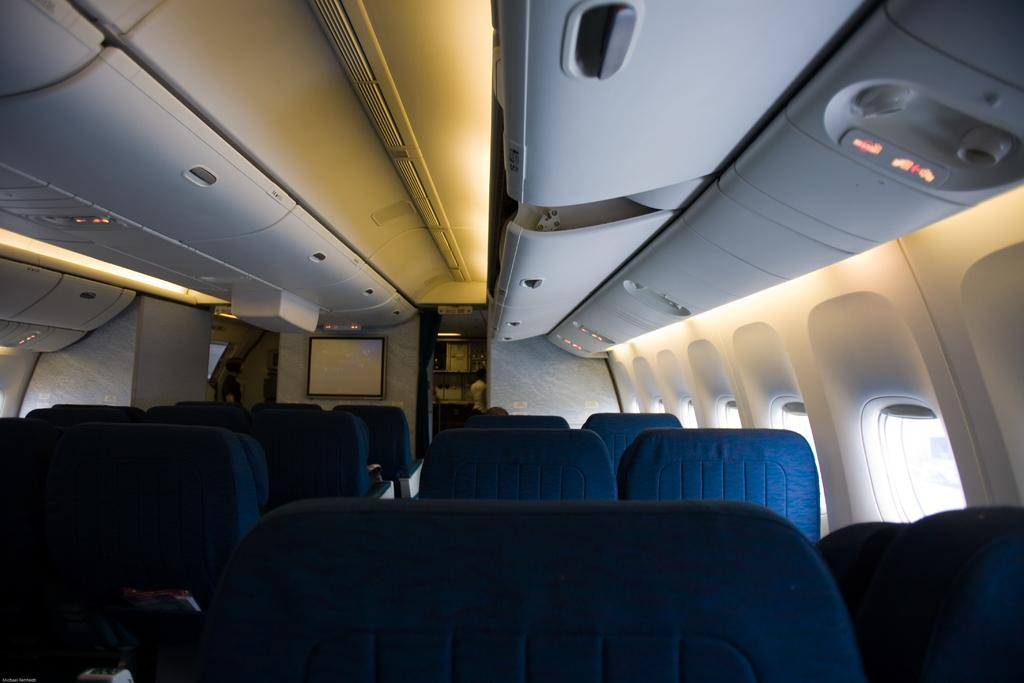What type of location might the image have been taken in? The image might have been taken in an aeroplane. What can be seen in the image that people might sit on? There are seats in the image. What allows passengers to see outside the aeroplane? There are windows in the image. What helps regulate the temperature inside the aeroplane? Air conditioners are visible in the image. What might passengers use to watch movies or shows during the flight? There is a screen in the image. What invention can be seen on the edge of the slip in the image? There is no invention or slip present in the image; it features an aeroplane interior. 